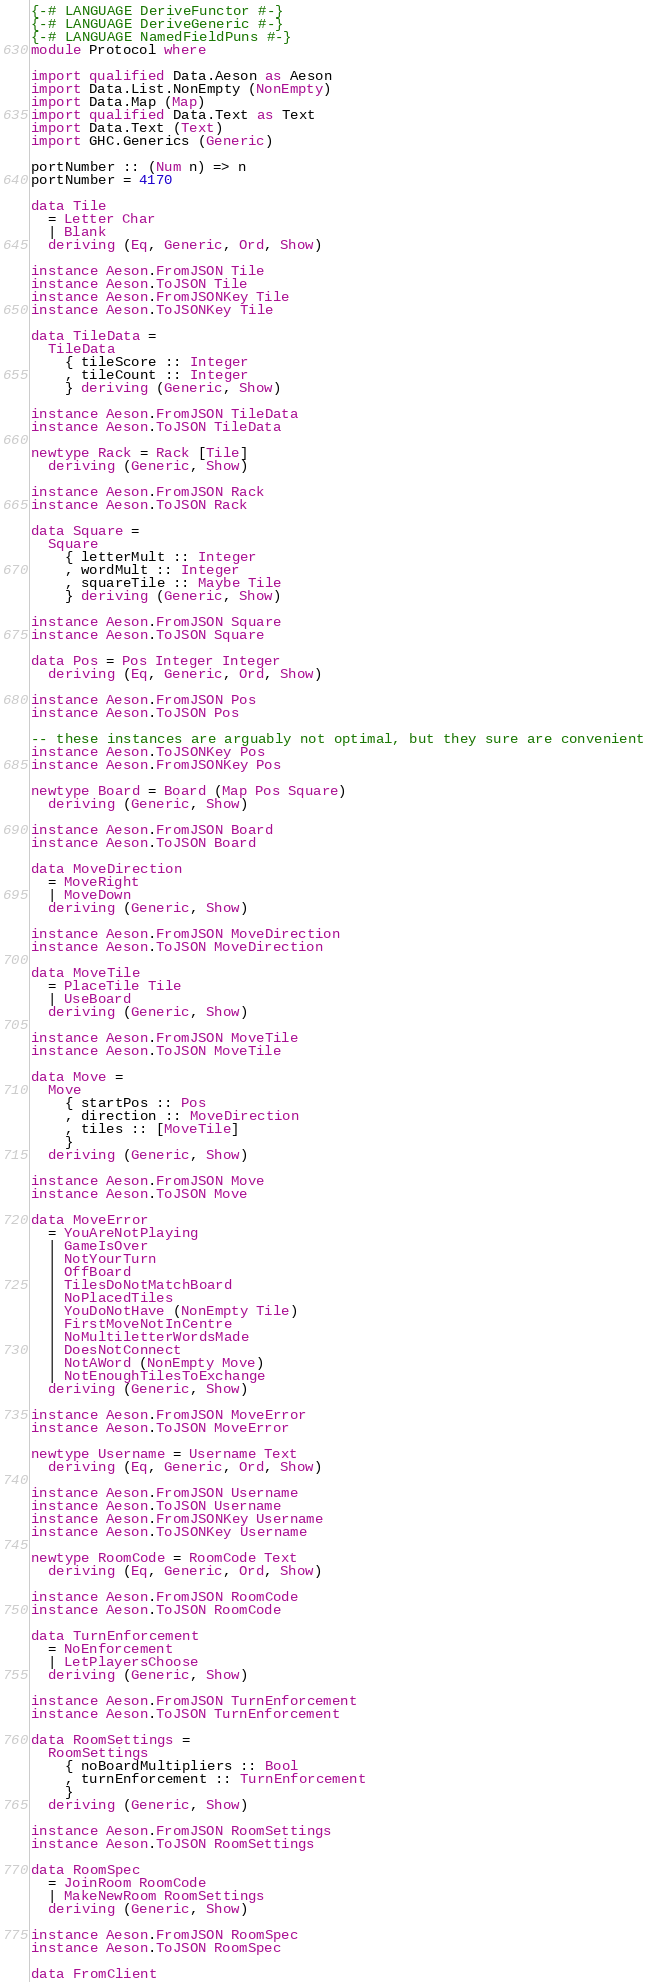<code> <loc_0><loc_0><loc_500><loc_500><_Haskell_>{-# LANGUAGE DeriveFunctor #-}
{-# LANGUAGE DeriveGeneric #-}
{-# LANGUAGE NamedFieldPuns #-}
module Protocol where

import qualified Data.Aeson as Aeson
import Data.List.NonEmpty (NonEmpty)
import Data.Map (Map)
import qualified Data.Text as Text
import Data.Text (Text)
import GHC.Generics (Generic)

portNumber :: (Num n) => n
portNumber = 4170

data Tile
  = Letter Char
  | Blank
  deriving (Eq, Generic, Ord, Show)

instance Aeson.FromJSON Tile
instance Aeson.ToJSON Tile
instance Aeson.FromJSONKey Tile
instance Aeson.ToJSONKey Tile

data TileData =
  TileData
    { tileScore :: Integer
    , tileCount :: Integer
    } deriving (Generic, Show)

instance Aeson.FromJSON TileData
instance Aeson.ToJSON TileData

newtype Rack = Rack [Tile]
  deriving (Generic, Show)

instance Aeson.FromJSON Rack
instance Aeson.ToJSON Rack

data Square =
  Square
    { letterMult :: Integer
    , wordMult :: Integer
    , squareTile :: Maybe Tile
    } deriving (Generic, Show)

instance Aeson.FromJSON Square
instance Aeson.ToJSON Square

data Pos = Pos Integer Integer
  deriving (Eq, Generic, Ord, Show)

instance Aeson.FromJSON Pos
instance Aeson.ToJSON Pos

-- these instances are arguably not optimal, but they sure are convenient
instance Aeson.ToJSONKey Pos
instance Aeson.FromJSONKey Pos

newtype Board = Board (Map Pos Square)
  deriving (Generic, Show)

instance Aeson.FromJSON Board
instance Aeson.ToJSON Board

data MoveDirection
  = MoveRight
  | MoveDown
  deriving (Generic, Show)

instance Aeson.FromJSON MoveDirection
instance Aeson.ToJSON MoveDirection

data MoveTile
  = PlaceTile Tile
  | UseBoard
  deriving (Generic, Show)

instance Aeson.FromJSON MoveTile
instance Aeson.ToJSON MoveTile

data Move =
  Move
    { startPos :: Pos
    , direction :: MoveDirection
    , tiles :: [MoveTile]
    }
  deriving (Generic, Show)

instance Aeson.FromJSON Move
instance Aeson.ToJSON Move

data MoveError
  = YouAreNotPlaying
  | GameIsOver
  | NotYourTurn
  | OffBoard
  | TilesDoNotMatchBoard
  | NoPlacedTiles
  | YouDoNotHave (NonEmpty Tile)
  | FirstMoveNotInCentre
  | NoMultiletterWordsMade
  | DoesNotConnect
  | NotAWord (NonEmpty Move)
  | NotEnoughTilesToExchange
  deriving (Generic, Show)

instance Aeson.FromJSON MoveError
instance Aeson.ToJSON MoveError

newtype Username = Username Text
  deriving (Eq, Generic, Ord, Show)

instance Aeson.FromJSON Username
instance Aeson.ToJSON Username
instance Aeson.FromJSONKey Username
instance Aeson.ToJSONKey Username

newtype RoomCode = RoomCode Text
  deriving (Eq, Generic, Ord, Show)

instance Aeson.FromJSON RoomCode
instance Aeson.ToJSON RoomCode

data TurnEnforcement
  = NoEnforcement
  | LetPlayersChoose
  deriving (Generic, Show)

instance Aeson.FromJSON TurnEnforcement
instance Aeson.ToJSON TurnEnforcement

data RoomSettings =
  RoomSettings
    { noBoardMultipliers :: Bool
    , turnEnforcement :: TurnEnforcement
    }
  deriving (Generic, Show)

instance Aeson.FromJSON RoomSettings
instance Aeson.ToJSON RoomSettings

data RoomSpec
  = JoinRoom RoomCode
  | MakeNewRoom RoomSettings
  deriving (Generic, Show)

instance Aeson.FromJSON RoomSpec
instance Aeson.ToJSON RoomSpec

data FromClient</code> 